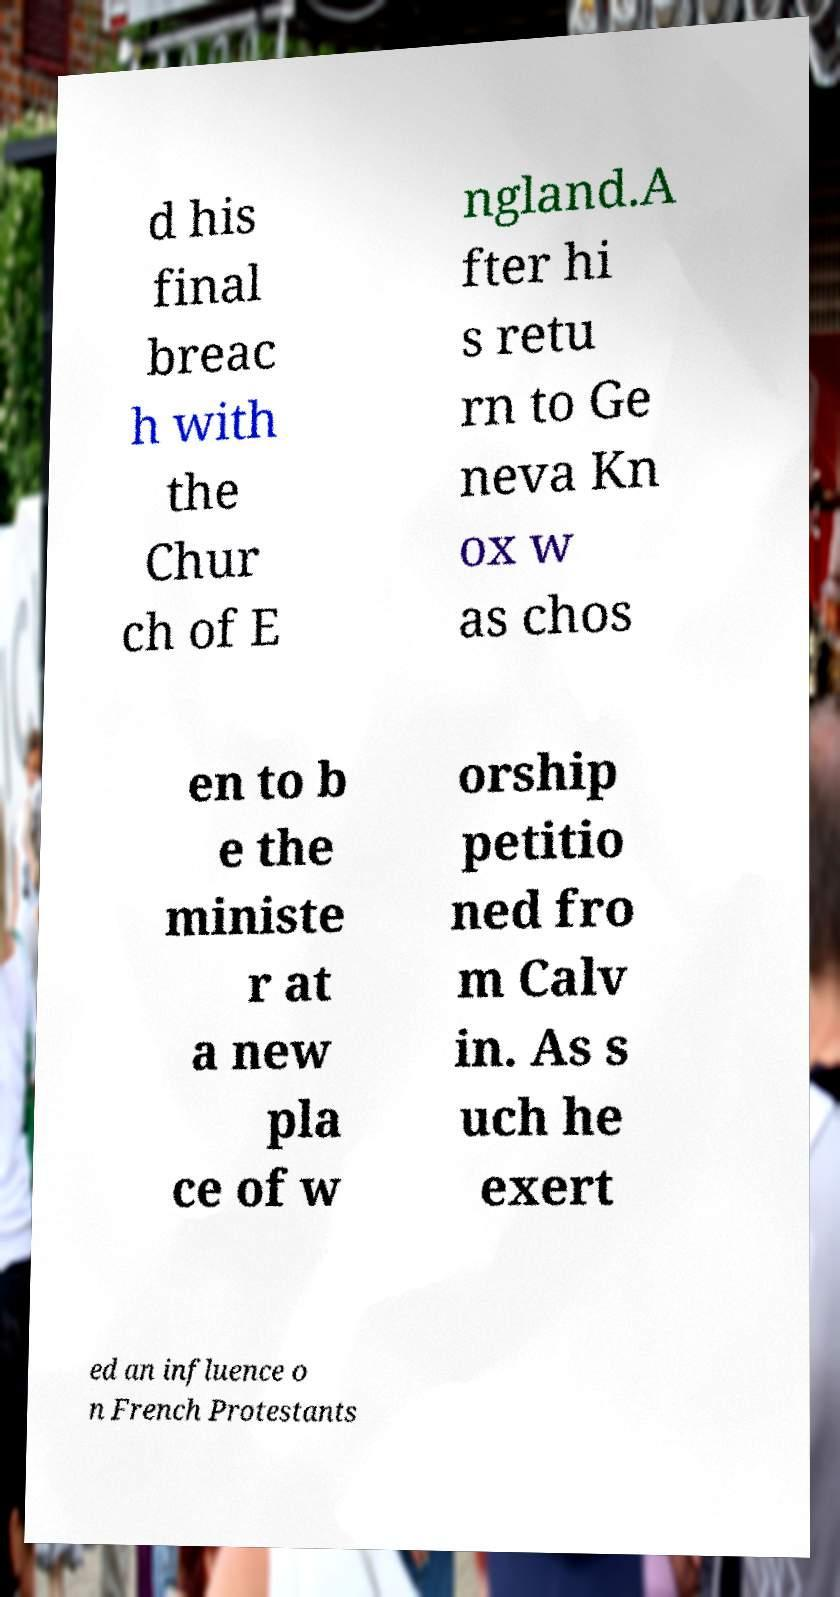Can you read and provide the text displayed in the image?This photo seems to have some interesting text. Can you extract and type it out for me? d his final breac h with the Chur ch of E ngland.A fter hi s retu rn to Ge neva Kn ox w as chos en to b e the ministe r at a new pla ce of w orship petitio ned fro m Calv in. As s uch he exert ed an influence o n French Protestants 